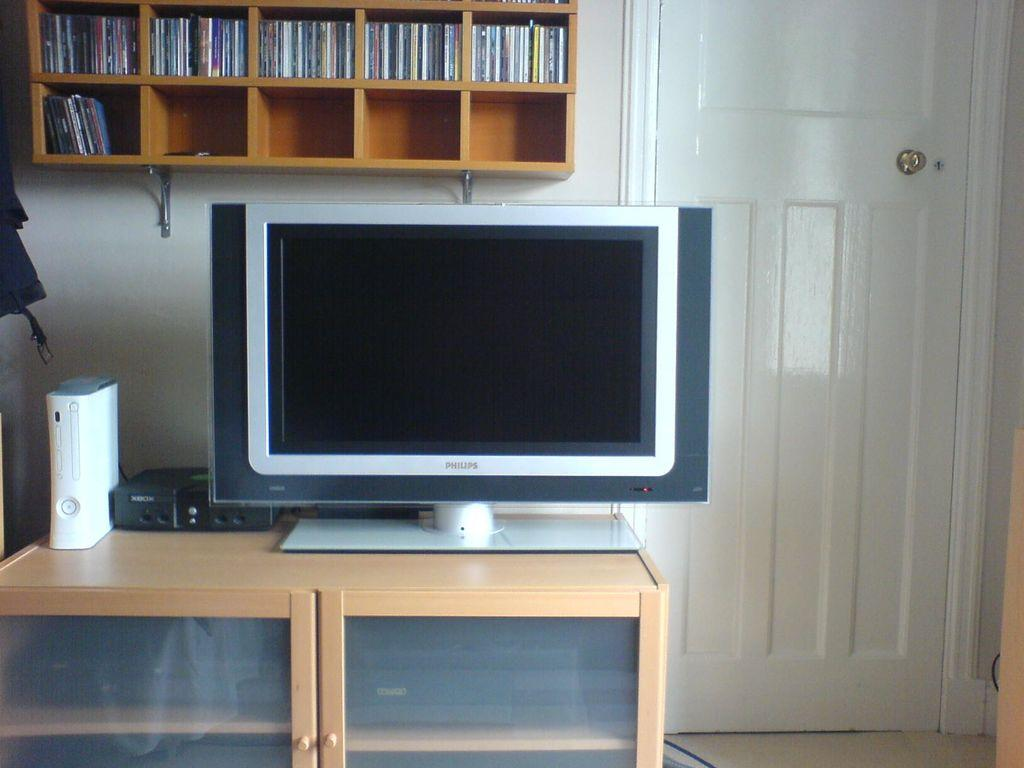What is the main object in the image? There is a screen in the image. What other objects can be seen in the image? There is a sound box, a cupboard, shelves, and a door in the image. What is the purpose of the shelves in the image? The shelves are used to hold objects, as there are objects on the shelves. What type of floor is visible in the image? The image shows a floor. What type of pie is being served on the board in the image? There is no pie or board present in the image. What type of pan is visible on the shelves in the image? There is no pan visible on the shelves in the image. 